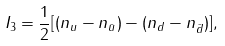<formula> <loc_0><loc_0><loc_500><loc_500>I _ { 3 } = { \frac { 1 } { 2 } } [ ( n _ { u } - n _ { \bar { u } } ) - ( n _ { d } - n _ { \bar { d } } ) ] ,</formula> 